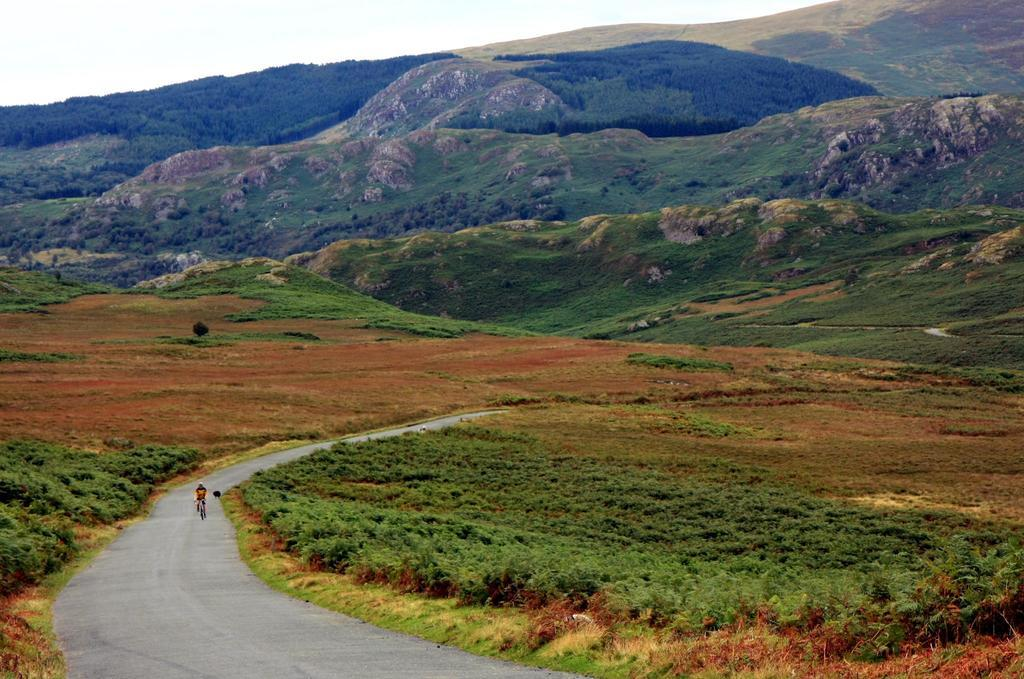What is at the bottom of the image? There is a road at the bottom of the image. What is happening on the road? A person is riding a bicycle on the road. What can be seen in the distance in the image? There are hills visible in the background of the image. What else is visible in the background of the image? The sky is visible in the background of the image. Can you see any fire or flames on the bicycle in the image? No, there is no fire or flames visible on the bicycle or anywhere in the image. 